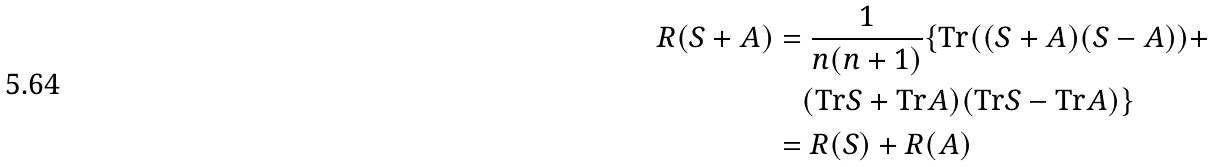Convert formula to latex. <formula><loc_0><loc_0><loc_500><loc_500>R ( S + A ) & = \frac { 1 } { n ( n + 1 ) } \{ \text {Tr} ( ( S + A ) ( S - A ) ) + \\ & \quad ( \text {Tr} S + \text {Tr} A ) ( \text {Tr} S - \text {Tr} A ) \} \\ & = R ( S ) + R ( A )</formula> 